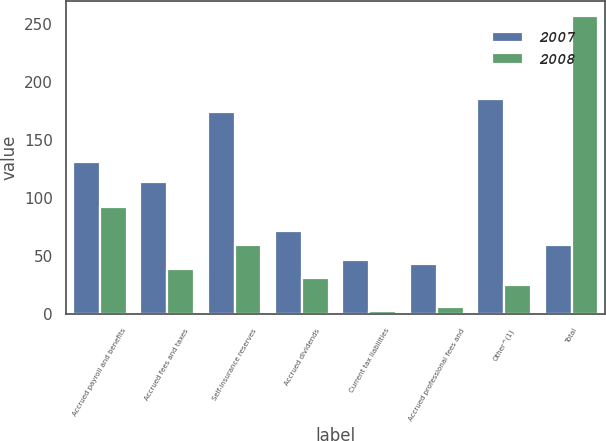Convert chart. <chart><loc_0><loc_0><loc_500><loc_500><stacked_bar_chart><ecel><fcel>Accrued payroll and benefits<fcel>Accrued fees and taxes<fcel>Self-insurance reserves<fcel>Accrued dividends<fcel>Current tax liabilities<fcel>Accrued professional fees and<fcel>Other^(1)<fcel>Total<nl><fcel>2007<fcel>130.6<fcel>114<fcel>173.6<fcel>72<fcel>47.1<fcel>43.7<fcel>185.4<fcel>59.5<nl><fcel>2008<fcel>92.6<fcel>38.9<fcel>59.5<fcel>31.6<fcel>2.5<fcel>6<fcel>25.3<fcel>256.4<nl></chart> 